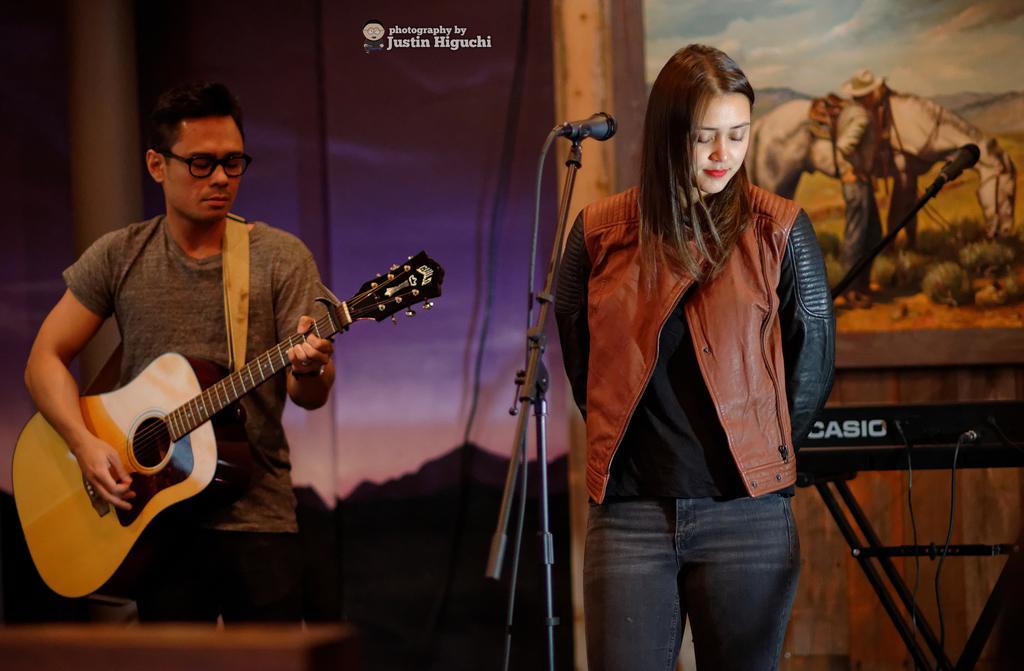Describe this image in one or two sentences. These two persons are standing and this person playing guitar,in front of this person we can see microphone with stand. On the background we can see wall,frame,musical instrument,microphone. 